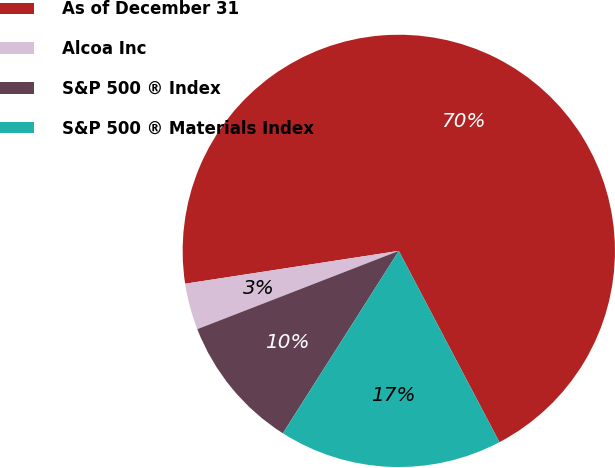<chart> <loc_0><loc_0><loc_500><loc_500><pie_chart><fcel>As of December 31<fcel>Alcoa Inc<fcel>S&P 500 ® Index<fcel>S&P 500 ® Materials Index<nl><fcel>69.72%<fcel>3.47%<fcel>10.09%<fcel>16.72%<nl></chart> 